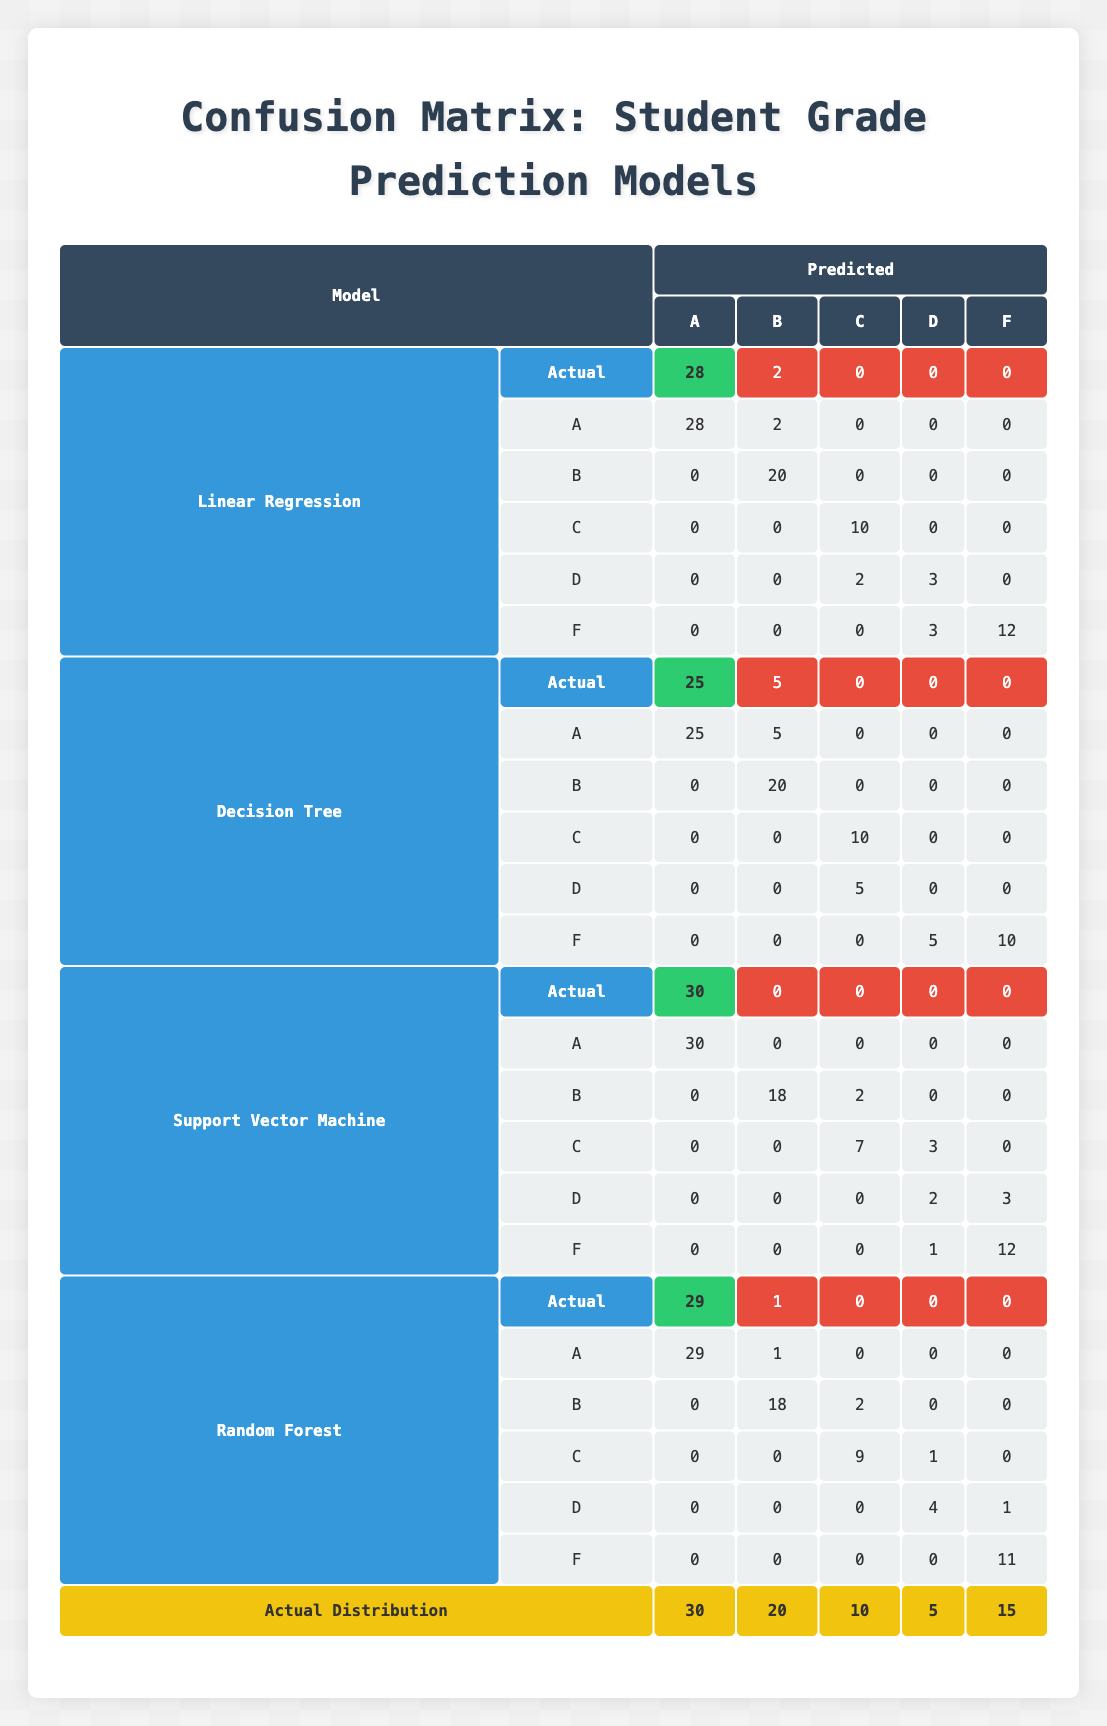What is the predicted count of grade A for the Support Vector Machine model? In the row for the Support Vector Machine model under the "Predicted" section, the value associated with grade A is 30.
Answer: 30 What is the total number of students predicted to receive grade F by the Decision Tree model? For grade F in the Decision Tree model's prediction, the count is 10.
Answer: 10 Does the Random Forest model predict any students to receive a grade D? Looking at the predictions for grade D under the Random Forest model, the count is 4, which means yes.
Answer: Yes What is the difference in the predicted count for grade C between the Random Forest and Linear Regression models? The predicted count for grade C in Random Forest is 9, while in Linear Regression it is 12. The difference is 12 - 9 = 3.
Answer: 3 Which model has the highest predicted count for grade B? By comparing the predicted counts for grade B across all models, the Decision Tree model has the highest prediction with a count of 25.
Answer: Decision Tree How many students were predicted to receive grades A and B combined by the Linear Regression model? The predictions for grades A and B under the Linear Regression model are 28 and 22 respectively. Combining these gives 28 + 22 = 50.
Answer: 50 What is the total actual count of students receiving grade D across all models? The actual count for grade D across all models is 5 (for Linear Regression) + 5 (for Decision Tree) + 5 (for Support Vector Machine) + 5 (for Random Forest) = 20.
Answer: 20 Is the predicted count for grade A in the Random Forest model less than that in the Support Vector Machine model? In Random Forest, the predicted count for grade A is 29, while in Support Vector Machine, it's 30, so the statement is true.
Answer: Yes How does the total predicted count for grades F compare between the Linear Regression and Random Forest models? The predicted count for grade F in Linear Regression is 12 and in Random Forest it is 11. Since 12 > 11, Linear Regression has a higher predicted count for grade F.
Answer: Higher in Linear Regression 